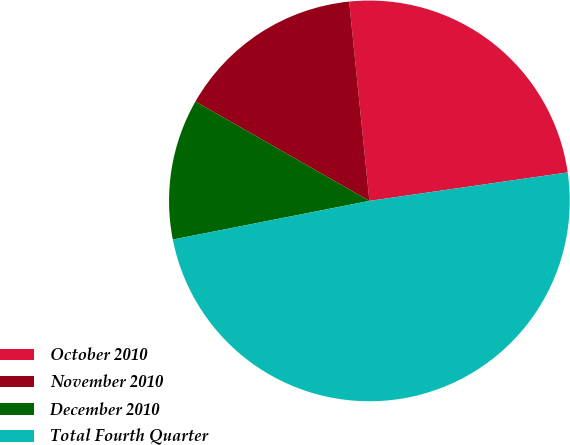Convert chart. <chart><loc_0><loc_0><loc_500><loc_500><pie_chart><fcel>October 2010<fcel>November 2010<fcel>December 2010<fcel>Total Fourth Quarter<nl><fcel>24.34%<fcel>15.13%<fcel>11.35%<fcel>49.18%<nl></chart> 